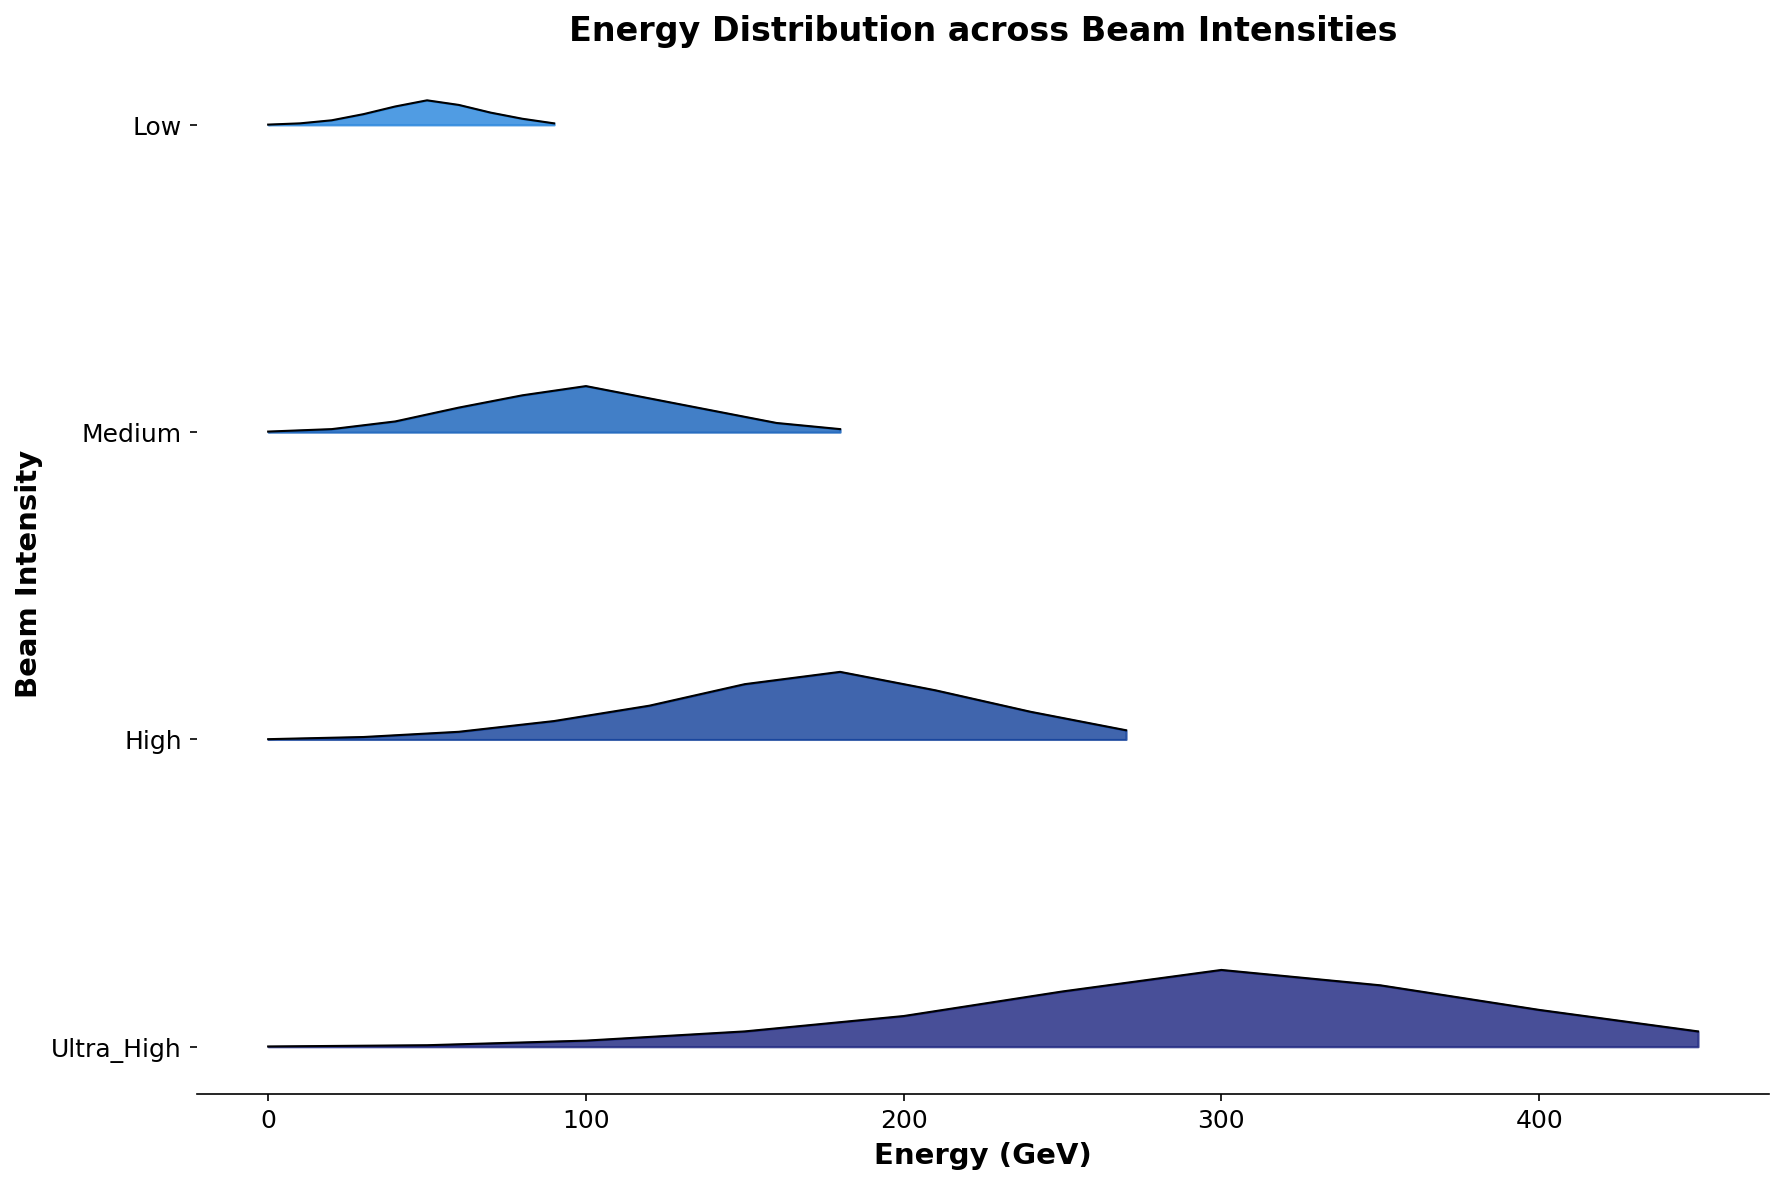What is the title of the plot? The title is written at the top center of the plot and provides a summary of what the plot is about.
Answer: Energy Distribution across Beam Intensities How many unique beam intensities are represented in the plot? Count the distinct labels on the y-axis of the plot.
Answer: 4 At which energy value does the 'Low' beam intensity reach its peak frequency? Observe the filled area for the 'Low' beam intensity and identify the energy value where the curve reaches its highest point.
Answer: 50 GeV Which beam intensity shows the widest range of energy values? Compare the range of the x-axis values for each beam intensity. The widest range will have the most spread-out values.
Answer: Ultra_High Which beam intensity has the highest peak frequency overall, and what is the energy value at this peak? Find the intensity where the peak of its curve reaches the maximum frequency value, then note the corresponding energy value from the x-axis.
Answer: Ultra_High, 300 GeV How does the peak frequency of 'High' beam intensity compare to that of 'Medium'? Compare the maximum frequency values of the 'High' and 'Medium' curves.
Answer: High's peak is higher than Medium's What is the difference in peak energy values between the 'Medium' and 'High' beam intensities? Identify the energy values at which 'Medium' and 'High' intensities peak, then calculate the difference.
Answer: 80 GeV Which beam intensities have their peak frequencies at energy values that are multiples of 50 GeV? Observe each curve and check if their peak frequency occurs at an energy value that is a multiple of 50.
Answer: Low, Ultra_High At what energy value does the 'Medium' beam intensity first start to have a non-zero frequency? Identify the lowest energy value on the x-axis where the 'Medium' curve begins to rise above zero.
Answer: 20 GeV For the 'High' beam intensity, what is the sum of frequencies at 120 GeV and 180 GeV? Locate the frequencies at 120 GeV and 180 GeV for the 'High' beam intensity and add them together.
Answer: 0.33 